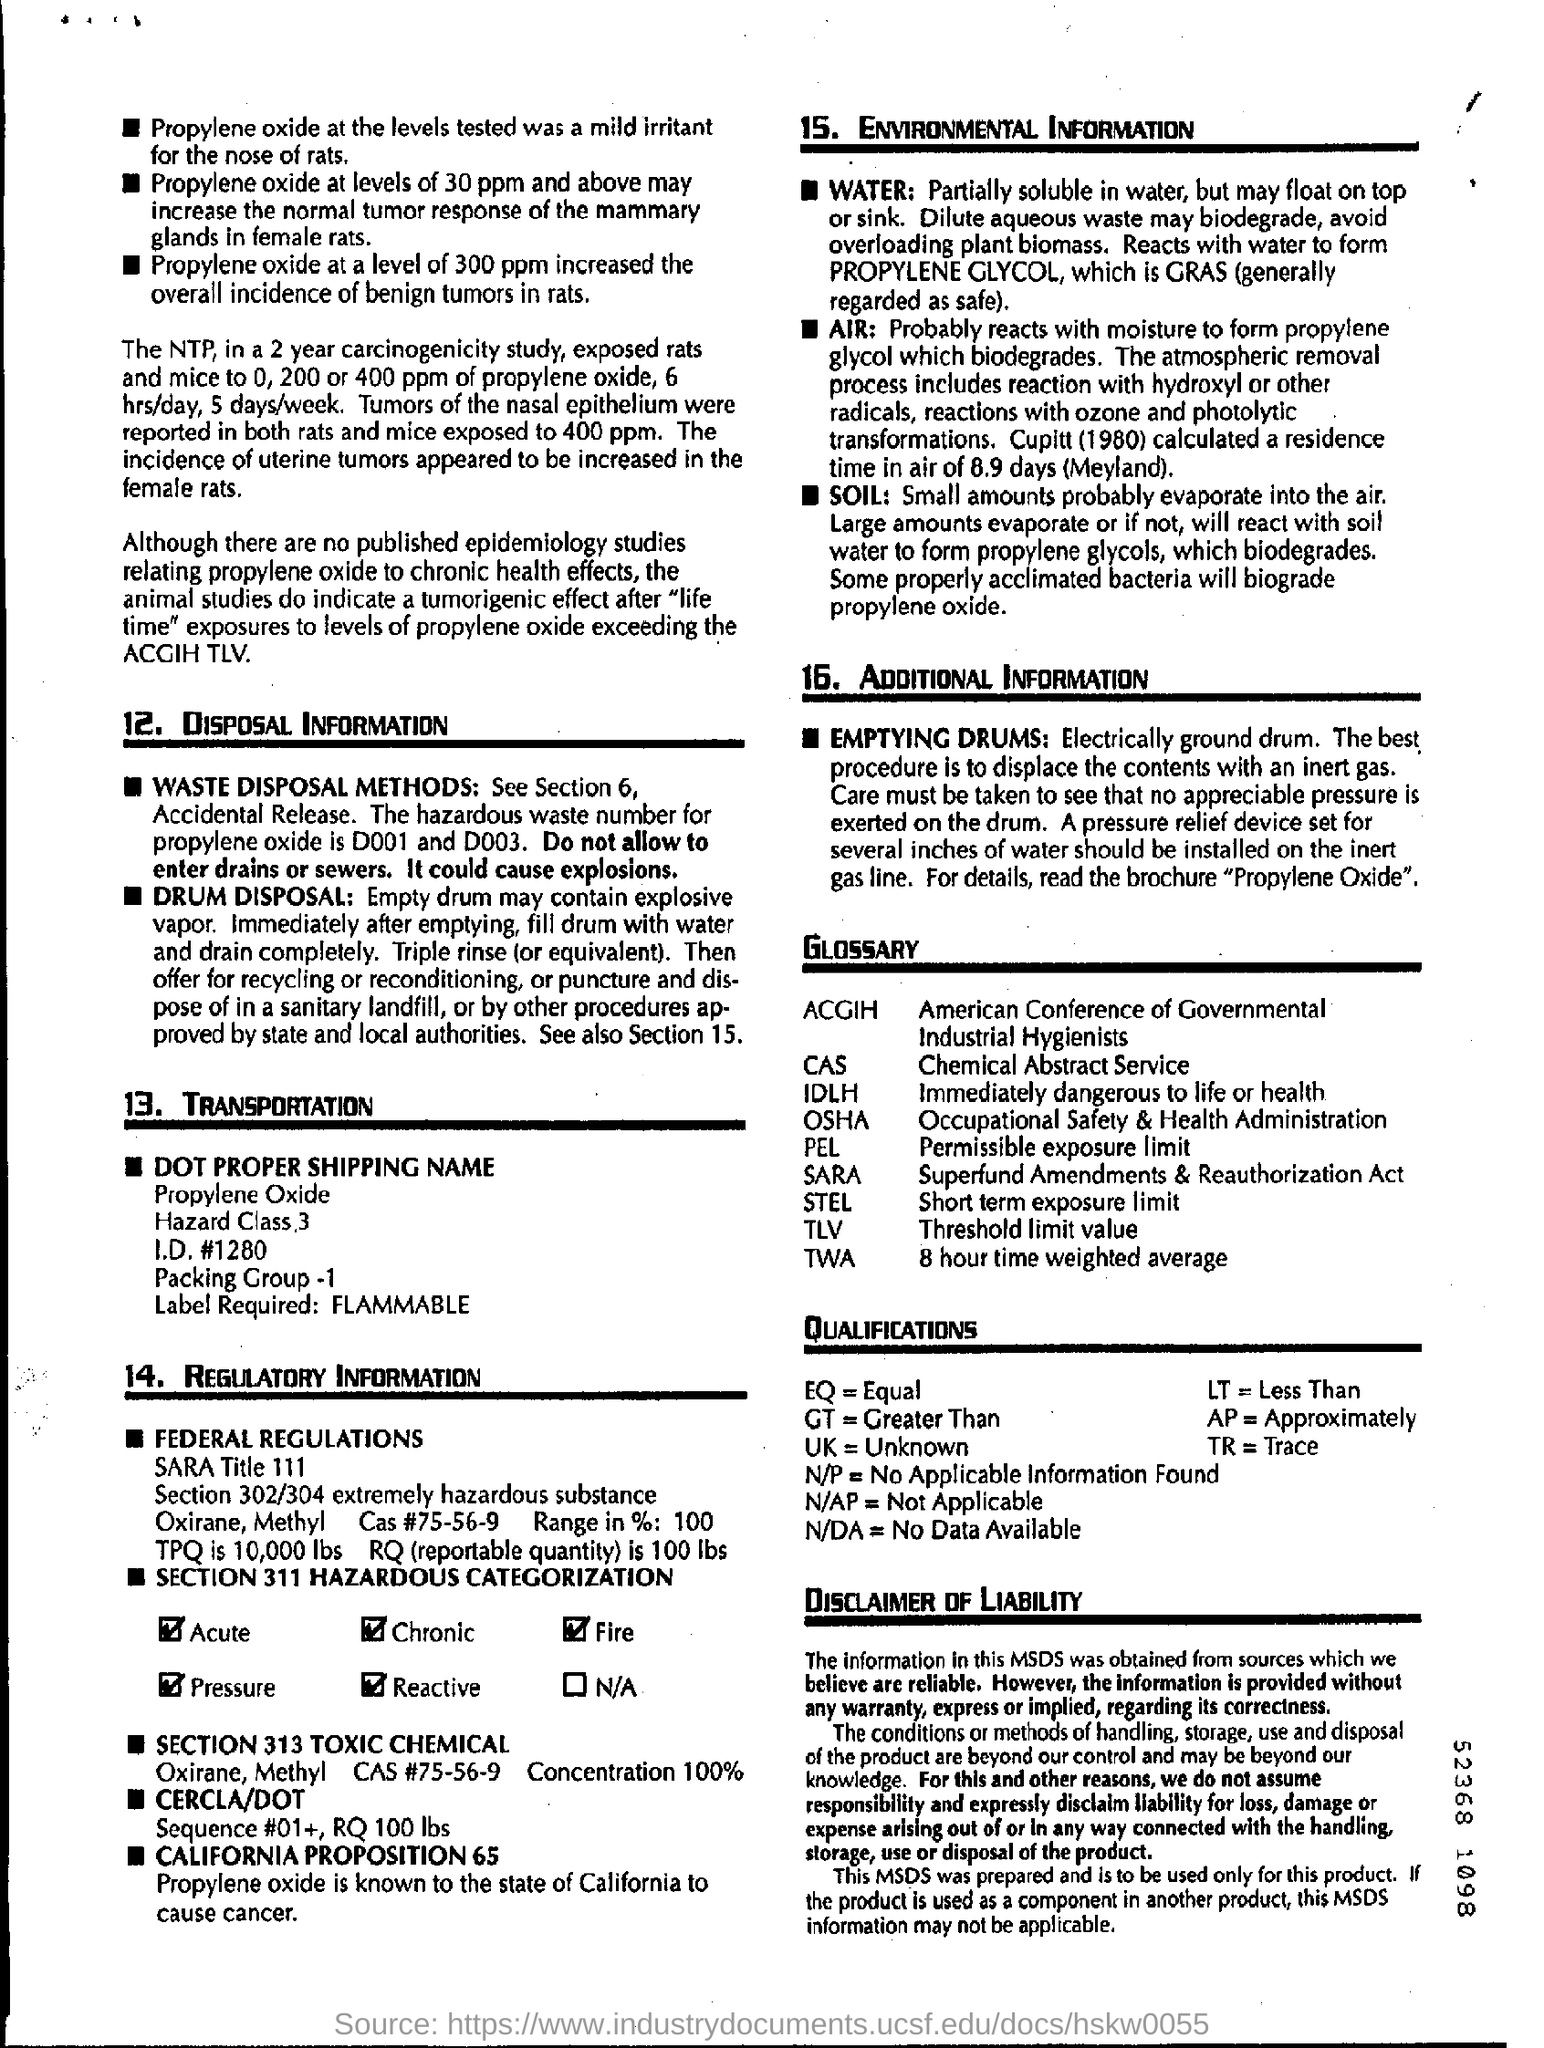Identify some key points in this picture. The study found that at a concentration of 300 ppm, propylene oxide increased the incidence of benign tumors in rats. The product resulting from the reaction between propylene oxide and water is known as a GRAS substance. ACGIH is an acronym that stands for the American Conference of Governmental Industrial Hygienists. TLV refers to the Threshold Limit Value, a measure used to define safe levels of exposure to certain substances. Propylene oxide is classified as a hazardous waste with the hazardous waste numbers D001 and D003. 